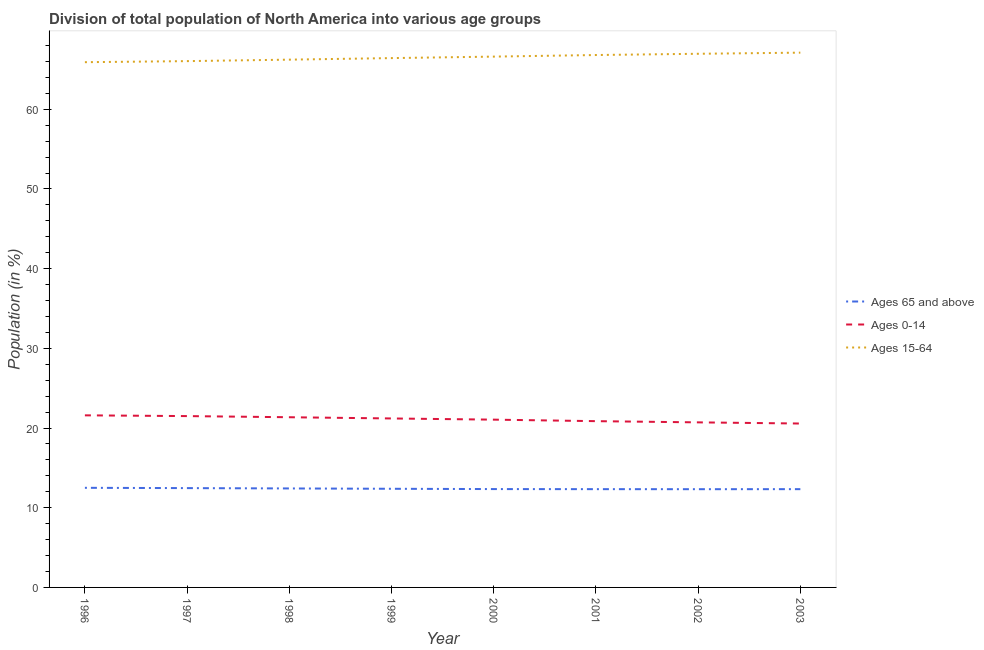How many different coloured lines are there?
Make the answer very short. 3. Does the line corresponding to percentage of population within the age-group 0-14 intersect with the line corresponding to percentage of population within the age-group of 65 and above?
Offer a terse response. No. Is the number of lines equal to the number of legend labels?
Offer a terse response. Yes. What is the percentage of population within the age-group of 65 and above in 1996?
Your answer should be compact. 12.5. Across all years, what is the maximum percentage of population within the age-group of 65 and above?
Ensure brevity in your answer.  12.5. Across all years, what is the minimum percentage of population within the age-group 0-14?
Provide a succinct answer. 20.57. What is the total percentage of population within the age-group of 65 and above in the graph?
Offer a very short reply. 99.09. What is the difference between the percentage of population within the age-group 0-14 in 1998 and that in 2003?
Make the answer very short. 0.79. What is the difference between the percentage of population within the age-group of 65 and above in 1996 and the percentage of population within the age-group 15-64 in 1998?
Offer a terse response. -53.73. What is the average percentage of population within the age-group of 65 and above per year?
Your response must be concise. 12.39. In the year 1998, what is the difference between the percentage of population within the age-group 0-14 and percentage of population within the age-group 15-64?
Offer a very short reply. -44.87. What is the ratio of the percentage of population within the age-group of 65 and above in 1999 to that in 2001?
Ensure brevity in your answer.  1. Is the percentage of population within the age-group 15-64 in 1999 less than that in 2002?
Offer a very short reply. Yes. Is the difference between the percentage of population within the age-group of 65 and above in 1998 and 1999 greater than the difference between the percentage of population within the age-group 0-14 in 1998 and 1999?
Your response must be concise. No. What is the difference between the highest and the second highest percentage of population within the age-group 0-14?
Provide a succinct answer. 0.1. What is the difference between the highest and the lowest percentage of population within the age-group 15-64?
Make the answer very short. 1.2. In how many years, is the percentage of population within the age-group of 65 and above greater than the average percentage of population within the age-group of 65 and above taken over all years?
Your answer should be compact. 3. Is the sum of the percentage of population within the age-group 0-14 in 1997 and 1998 greater than the maximum percentage of population within the age-group of 65 and above across all years?
Offer a terse response. Yes. Is the percentage of population within the age-group of 65 and above strictly less than the percentage of population within the age-group 15-64 over the years?
Ensure brevity in your answer.  Yes. How many lines are there?
Your response must be concise. 3. Are the values on the major ticks of Y-axis written in scientific E-notation?
Make the answer very short. No. Does the graph contain any zero values?
Offer a terse response. No. Does the graph contain grids?
Give a very brief answer. No. What is the title of the graph?
Provide a succinct answer. Division of total population of North America into various age groups
. What is the label or title of the X-axis?
Offer a terse response. Year. What is the label or title of the Y-axis?
Provide a short and direct response. Population (in %). What is the Population (in %) in Ages 65 and above in 1996?
Offer a very short reply. 12.5. What is the Population (in %) in Ages 0-14 in 1996?
Make the answer very short. 21.59. What is the Population (in %) in Ages 15-64 in 1996?
Your answer should be very brief. 65.91. What is the Population (in %) of Ages 65 and above in 1997?
Provide a succinct answer. 12.46. What is the Population (in %) of Ages 0-14 in 1997?
Provide a succinct answer. 21.5. What is the Population (in %) in Ages 15-64 in 1997?
Your answer should be compact. 66.04. What is the Population (in %) in Ages 65 and above in 1998?
Give a very brief answer. 12.42. What is the Population (in %) of Ages 0-14 in 1998?
Ensure brevity in your answer.  21.36. What is the Population (in %) in Ages 15-64 in 1998?
Provide a short and direct response. 66.22. What is the Population (in %) of Ages 65 and above in 1999?
Provide a succinct answer. 12.38. What is the Population (in %) of Ages 0-14 in 1999?
Your answer should be compact. 21.2. What is the Population (in %) of Ages 15-64 in 1999?
Provide a short and direct response. 66.42. What is the Population (in %) of Ages 65 and above in 2000?
Ensure brevity in your answer.  12.34. What is the Population (in %) in Ages 0-14 in 2000?
Provide a succinct answer. 21.05. What is the Population (in %) in Ages 15-64 in 2000?
Offer a terse response. 66.61. What is the Population (in %) of Ages 65 and above in 2001?
Keep it short and to the point. 12.33. What is the Population (in %) of Ages 0-14 in 2001?
Your response must be concise. 20.86. What is the Population (in %) of Ages 15-64 in 2001?
Ensure brevity in your answer.  66.81. What is the Population (in %) in Ages 65 and above in 2002?
Make the answer very short. 12.33. What is the Population (in %) of Ages 0-14 in 2002?
Your answer should be very brief. 20.71. What is the Population (in %) of Ages 15-64 in 2002?
Provide a short and direct response. 66.96. What is the Population (in %) in Ages 65 and above in 2003?
Provide a succinct answer. 12.33. What is the Population (in %) of Ages 0-14 in 2003?
Your answer should be very brief. 20.57. What is the Population (in %) of Ages 15-64 in 2003?
Offer a terse response. 67.1. Across all years, what is the maximum Population (in %) in Ages 65 and above?
Offer a very short reply. 12.5. Across all years, what is the maximum Population (in %) of Ages 0-14?
Your answer should be compact. 21.59. Across all years, what is the maximum Population (in %) in Ages 15-64?
Provide a succinct answer. 67.1. Across all years, what is the minimum Population (in %) in Ages 65 and above?
Keep it short and to the point. 12.33. Across all years, what is the minimum Population (in %) of Ages 0-14?
Your answer should be compact. 20.57. Across all years, what is the minimum Population (in %) in Ages 15-64?
Your answer should be very brief. 65.91. What is the total Population (in %) in Ages 65 and above in the graph?
Your answer should be compact. 99.09. What is the total Population (in %) of Ages 0-14 in the graph?
Give a very brief answer. 168.84. What is the total Population (in %) of Ages 15-64 in the graph?
Offer a terse response. 532.07. What is the difference between the Population (in %) in Ages 65 and above in 1996 and that in 1997?
Provide a short and direct response. 0.04. What is the difference between the Population (in %) in Ages 0-14 in 1996 and that in 1997?
Ensure brevity in your answer.  0.1. What is the difference between the Population (in %) of Ages 15-64 in 1996 and that in 1997?
Your answer should be compact. -0.13. What is the difference between the Population (in %) in Ages 65 and above in 1996 and that in 1998?
Your answer should be very brief. 0.08. What is the difference between the Population (in %) of Ages 0-14 in 1996 and that in 1998?
Give a very brief answer. 0.24. What is the difference between the Population (in %) in Ages 15-64 in 1996 and that in 1998?
Provide a succinct answer. -0.32. What is the difference between the Population (in %) in Ages 65 and above in 1996 and that in 1999?
Give a very brief answer. 0.12. What is the difference between the Population (in %) in Ages 0-14 in 1996 and that in 1999?
Your answer should be very brief. 0.39. What is the difference between the Population (in %) in Ages 15-64 in 1996 and that in 1999?
Offer a very short reply. -0.51. What is the difference between the Population (in %) of Ages 65 and above in 1996 and that in 2000?
Make the answer very short. 0.16. What is the difference between the Population (in %) of Ages 0-14 in 1996 and that in 2000?
Your answer should be very brief. 0.54. What is the difference between the Population (in %) of Ages 15-64 in 1996 and that in 2000?
Your response must be concise. -0.7. What is the difference between the Population (in %) of Ages 65 and above in 1996 and that in 2001?
Your answer should be very brief. 0.17. What is the difference between the Population (in %) of Ages 0-14 in 1996 and that in 2001?
Offer a terse response. 0.73. What is the difference between the Population (in %) of Ages 15-64 in 1996 and that in 2001?
Provide a succinct answer. -0.9. What is the difference between the Population (in %) in Ages 65 and above in 1996 and that in 2002?
Offer a very short reply. 0.17. What is the difference between the Population (in %) of Ages 0-14 in 1996 and that in 2002?
Provide a short and direct response. 0.88. What is the difference between the Population (in %) of Ages 15-64 in 1996 and that in 2002?
Your answer should be very brief. -1.06. What is the difference between the Population (in %) in Ages 65 and above in 1996 and that in 2003?
Provide a short and direct response. 0.17. What is the difference between the Population (in %) of Ages 0-14 in 1996 and that in 2003?
Provide a short and direct response. 1.03. What is the difference between the Population (in %) in Ages 15-64 in 1996 and that in 2003?
Your response must be concise. -1.2. What is the difference between the Population (in %) of Ages 65 and above in 1997 and that in 1998?
Keep it short and to the point. 0.04. What is the difference between the Population (in %) of Ages 0-14 in 1997 and that in 1998?
Make the answer very short. 0.14. What is the difference between the Population (in %) of Ages 15-64 in 1997 and that in 1998?
Your response must be concise. -0.19. What is the difference between the Population (in %) of Ages 65 and above in 1997 and that in 1999?
Give a very brief answer. 0.08. What is the difference between the Population (in %) of Ages 0-14 in 1997 and that in 1999?
Your answer should be very brief. 0.3. What is the difference between the Population (in %) in Ages 15-64 in 1997 and that in 1999?
Keep it short and to the point. -0.38. What is the difference between the Population (in %) in Ages 65 and above in 1997 and that in 2000?
Offer a terse response. 0.12. What is the difference between the Population (in %) in Ages 0-14 in 1997 and that in 2000?
Your answer should be very brief. 0.45. What is the difference between the Population (in %) in Ages 15-64 in 1997 and that in 2000?
Your answer should be very brief. -0.57. What is the difference between the Population (in %) of Ages 65 and above in 1997 and that in 2001?
Your answer should be compact. 0.13. What is the difference between the Population (in %) of Ages 0-14 in 1997 and that in 2001?
Offer a terse response. 0.64. What is the difference between the Population (in %) of Ages 15-64 in 1997 and that in 2001?
Your answer should be compact. -0.77. What is the difference between the Population (in %) in Ages 65 and above in 1997 and that in 2002?
Offer a terse response. 0.14. What is the difference between the Population (in %) of Ages 0-14 in 1997 and that in 2002?
Provide a short and direct response. 0.79. What is the difference between the Population (in %) in Ages 15-64 in 1997 and that in 2002?
Make the answer very short. -0.92. What is the difference between the Population (in %) of Ages 65 and above in 1997 and that in 2003?
Your response must be concise. 0.13. What is the difference between the Population (in %) in Ages 0-14 in 1997 and that in 2003?
Offer a terse response. 0.93. What is the difference between the Population (in %) of Ages 15-64 in 1997 and that in 2003?
Your answer should be very brief. -1.06. What is the difference between the Population (in %) of Ages 65 and above in 1998 and that in 1999?
Your response must be concise. 0.04. What is the difference between the Population (in %) in Ages 0-14 in 1998 and that in 1999?
Keep it short and to the point. 0.15. What is the difference between the Population (in %) of Ages 15-64 in 1998 and that in 1999?
Keep it short and to the point. -0.2. What is the difference between the Population (in %) of Ages 65 and above in 1998 and that in 2000?
Offer a terse response. 0.08. What is the difference between the Population (in %) of Ages 0-14 in 1998 and that in 2000?
Provide a succinct answer. 0.3. What is the difference between the Population (in %) in Ages 15-64 in 1998 and that in 2000?
Your answer should be compact. -0.38. What is the difference between the Population (in %) of Ages 65 and above in 1998 and that in 2001?
Provide a succinct answer. 0.09. What is the difference between the Population (in %) of Ages 0-14 in 1998 and that in 2001?
Offer a very short reply. 0.49. What is the difference between the Population (in %) of Ages 15-64 in 1998 and that in 2001?
Give a very brief answer. -0.58. What is the difference between the Population (in %) in Ages 65 and above in 1998 and that in 2002?
Ensure brevity in your answer.  0.09. What is the difference between the Population (in %) in Ages 0-14 in 1998 and that in 2002?
Make the answer very short. 0.64. What is the difference between the Population (in %) of Ages 15-64 in 1998 and that in 2002?
Provide a short and direct response. -0.74. What is the difference between the Population (in %) of Ages 65 and above in 1998 and that in 2003?
Offer a terse response. 0.09. What is the difference between the Population (in %) of Ages 0-14 in 1998 and that in 2003?
Offer a very short reply. 0.79. What is the difference between the Population (in %) of Ages 15-64 in 1998 and that in 2003?
Your response must be concise. -0.88. What is the difference between the Population (in %) of Ages 65 and above in 1999 and that in 2000?
Your answer should be compact. 0.04. What is the difference between the Population (in %) of Ages 0-14 in 1999 and that in 2000?
Your answer should be very brief. 0.15. What is the difference between the Population (in %) of Ages 15-64 in 1999 and that in 2000?
Provide a succinct answer. -0.19. What is the difference between the Population (in %) of Ages 65 and above in 1999 and that in 2001?
Keep it short and to the point. 0.05. What is the difference between the Population (in %) of Ages 0-14 in 1999 and that in 2001?
Offer a terse response. 0.34. What is the difference between the Population (in %) of Ages 15-64 in 1999 and that in 2001?
Keep it short and to the point. -0.39. What is the difference between the Population (in %) of Ages 65 and above in 1999 and that in 2002?
Provide a short and direct response. 0.05. What is the difference between the Population (in %) in Ages 0-14 in 1999 and that in 2002?
Keep it short and to the point. 0.49. What is the difference between the Population (in %) of Ages 15-64 in 1999 and that in 2002?
Your answer should be compact. -0.54. What is the difference between the Population (in %) in Ages 65 and above in 1999 and that in 2003?
Make the answer very short. 0.05. What is the difference between the Population (in %) in Ages 0-14 in 1999 and that in 2003?
Your answer should be compact. 0.64. What is the difference between the Population (in %) in Ages 15-64 in 1999 and that in 2003?
Your response must be concise. -0.68. What is the difference between the Population (in %) in Ages 65 and above in 2000 and that in 2001?
Your answer should be compact. 0.01. What is the difference between the Population (in %) of Ages 0-14 in 2000 and that in 2001?
Keep it short and to the point. 0.19. What is the difference between the Population (in %) of Ages 15-64 in 2000 and that in 2001?
Make the answer very short. -0.2. What is the difference between the Population (in %) in Ages 65 and above in 2000 and that in 2002?
Offer a terse response. 0.01. What is the difference between the Population (in %) in Ages 0-14 in 2000 and that in 2002?
Make the answer very short. 0.34. What is the difference between the Population (in %) of Ages 15-64 in 2000 and that in 2002?
Make the answer very short. -0.36. What is the difference between the Population (in %) in Ages 65 and above in 2000 and that in 2003?
Offer a terse response. 0.01. What is the difference between the Population (in %) of Ages 0-14 in 2000 and that in 2003?
Provide a short and direct response. 0.49. What is the difference between the Population (in %) of Ages 15-64 in 2000 and that in 2003?
Your answer should be very brief. -0.5. What is the difference between the Population (in %) of Ages 65 and above in 2001 and that in 2002?
Ensure brevity in your answer.  0.01. What is the difference between the Population (in %) in Ages 0-14 in 2001 and that in 2002?
Your response must be concise. 0.15. What is the difference between the Population (in %) in Ages 15-64 in 2001 and that in 2002?
Offer a very short reply. -0.16. What is the difference between the Population (in %) of Ages 65 and above in 2001 and that in 2003?
Make the answer very short. -0. What is the difference between the Population (in %) of Ages 0-14 in 2001 and that in 2003?
Your answer should be compact. 0.3. What is the difference between the Population (in %) in Ages 15-64 in 2001 and that in 2003?
Offer a very short reply. -0.3. What is the difference between the Population (in %) in Ages 65 and above in 2002 and that in 2003?
Your answer should be compact. -0.01. What is the difference between the Population (in %) in Ages 0-14 in 2002 and that in 2003?
Keep it short and to the point. 0.15. What is the difference between the Population (in %) in Ages 15-64 in 2002 and that in 2003?
Offer a terse response. -0.14. What is the difference between the Population (in %) in Ages 65 and above in 1996 and the Population (in %) in Ages 0-14 in 1997?
Offer a terse response. -9. What is the difference between the Population (in %) in Ages 65 and above in 1996 and the Population (in %) in Ages 15-64 in 1997?
Ensure brevity in your answer.  -53.54. What is the difference between the Population (in %) of Ages 0-14 in 1996 and the Population (in %) of Ages 15-64 in 1997?
Your response must be concise. -44.45. What is the difference between the Population (in %) in Ages 65 and above in 1996 and the Population (in %) in Ages 0-14 in 1998?
Your answer should be compact. -8.86. What is the difference between the Population (in %) in Ages 65 and above in 1996 and the Population (in %) in Ages 15-64 in 1998?
Your answer should be compact. -53.73. What is the difference between the Population (in %) in Ages 0-14 in 1996 and the Population (in %) in Ages 15-64 in 1998?
Provide a short and direct response. -44.63. What is the difference between the Population (in %) in Ages 65 and above in 1996 and the Population (in %) in Ages 0-14 in 1999?
Your response must be concise. -8.7. What is the difference between the Population (in %) in Ages 65 and above in 1996 and the Population (in %) in Ages 15-64 in 1999?
Your response must be concise. -53.92. What is the difference between the Population (in %) of Ages 0-14 in 1996 and the Population (in %) of Ages 15-64 in 1999?
Keep it short and to the point. -44.83. What is the difference between the Population (in %) in Ages 65 and above in 1996 and the Population (in %) in Ages 0-14 in 2000?
Your response must be concise. -8.55. What is the difference between the Population (in %) of Ages 65 and above in 1996 and the Population (in %) of Ages 15-64 in 2000?
Keep it short and to the point. -54.11. What is the difference between the Population (in %) of Ages 0-14 in 1996 and the Population (in %) of Ages 15-64 in 2000?
Offer a very short reply. -45.01. What is the difference between the Population (in %) in Ages 65 and above in 1996 and the Population (in %) in Ages 0-14 in 2001?
Provide a succinct answer. -8.36. What is the difference between the Population (in %) in Ages 65 and above in 1996 and the Population (in %) in Ages 15-64 in 2001?
Offer a terse response. -54.31. What is the difference between the Population (in %) in Ages 0-14 in 1996 and the Population (in %) in Ages 15-64 in 2001?
Provide a short and direct response. -45.21. What is the difference between the Population (in %) of Ages 65 and above in 1996 and the Population (in %) of Ages 0-14 in 2002?
Offer a terse response. -8.21. What is the difference between the Population (in %) of Ages 65 and above in 1996 and the Population (in %) of Ages 15-64 in 2002?
Your answer should be very brief. -54.46. What is the difference between the Population (in %) in Ages 0-14 in 1996 and the Population (in %) in Ages 15-64 in 2002?
Your response must be concise. -45.37. What is the difference between the Population (in %) in Ages 65 and above in 1996 and the Population (in %) in Ages 0-14 in 2003?
Your answer should be very brief. -8.07. What is the difference between the Population (in %) of Ages 65 and above in 1996 and the Population (in %) of Ages 15-64 in 2003?
Keep it short and to the point. -54.6. What is the difference between the Population (in %) of Ages 0-14 in 1996 and the Population (in %) of Ages 15-64 in 2003?
Make the answer very short. -45.51. What is the difference between the Population (in %) of Ages 65 and above in 1997 and the Population (in %) of Ages 0-14 in 1998?
Your answer should be very brief. -8.89. What is the difference between the Population (in %) in Ages 65 and above in 1997 and the Population (in %) in Ages 15-64 in 1998?
Offer a terse response. -53.76. What is the difference between the Population (in %) of Ages 0-14 in 1997 and the Population (in %) of Ages 15-64 in 1998?
Your answer should be very brief. -44.73. What is the difference between the Population (in %) in Ages 65 and above in 1997 and the Population (in %) in Ages 0-14 in 1999?
Offer a very short reply. -8.74. What is the difference between the Population (in %) of Ages 65 and above in 1997 and the Population (in %) of Ages 15-64 in 1999?
Make the answer very short. -53.96. What is the difference between the Population (in %) of Ages 0-14 in 1997 and the Population (in %) of Ages 15-64 in 1999?
Your answer should be very brief. -44.92. What is the difference between the Population (in %) in Ages 65 and above in 1997 and the Population (in %) in Ages 0-14 in 2000?
Your answer should be very brief. -8.59. What is the difference between the Population (in %) of Ages 65 and above in 1997 and the Population (in %) of Ages 15-64 in 2000?
Your response must be concise. -54.14. What is the difference between the Population (in %) of Ages 0-14 in 1997 and the Population (in %) of Ages 15-64 in 2000?
Offer a very short reply. -45.11. What is the difference between the Population (in %) of Ages 65 and above in 1997 and the Population (in %) of Ages 0-14 in 2001?
Keep it short and to the point. -8.4. What is the difference between the Population (in %) in Ages 65 and above in 1997 and the Population (in %) in Ages 15-64 in 2001?
Your answer should be very brief. -54.34. What is the difference between the Population (in %) of Ages 0-14 in 1997 and the Population (in %) of Ages 15-64 in 2001?
Make the answer very short. -45.31. What is the difference between the Population (in %) of Ages 65 and above in 1997 and the Population (in %) of Ages 0-14 in 2002?
Give a very brief answer. -8.25. What is the difference between the Population (in %) in Ages 65 and above in 1997 and the Population (in %) in Ages 15-64 in 2002?
Provide a succinct answer. -54.5. What is the difference between the Population (in %) in Ages 0-14 in 1997 and the Population (in %) in Ages 15-64 in 2002?
Give a very brief answer. -45.46. What is the difference between the Population (in %) in Ages 65 and above in 1997 and the Population (in %) in Ages 0-14 in 2003?
Give a very brief answer. -8.1. What is the difference between the Population (in %) of Ages 65 and above in 1997 and the Population (in %) of Ages 15-64 in 2003?
Your answer should be compact. -54.64. What is the difference between the Population (in %) of Ages 0-14 in 1997 and the Population (in %) of Ages 15-64 in 2003?
Your answer should be very brief. -45.6. What is the difference between the Population (in %) in Ages 65 and above in 1998 and the Population (in %) in Ages 0-14 in 1999?
Provide a succinct answer. -8.78. What is the difference between the Population (in %) of Ages 65 and above in 1998 and the Population (in %) of Ages 15-64 in 1999?
Give a very brief answer. -54. What is the difference between the Population (in %) in Ages 0-14 in 1998 and the Population (in %) in Ages 15-64 in 1999?
Give a very brief answer. -45.06. What is the difference between the Population (in %) in Ages 65 and above in 1998 and the Population (in %) in Ages 0-14 in 2000?
Keep it short and to the point. -8.63. What is the difference between the Population (in %) of Ages 65 and above in 1998 and the Population (in %) of Ages 15-64 in 2000?
Provide a succinct answer. -54.19. What is the difference between the Population (in %) of Ages 0-14 in 1998 and the Population (in %) of Ages 15-64 in 2000?
Ensure brevity in your answer.  -45.25. What is the difference between the Population (in %) of Ages 65 and above in 1998 and the Population (in %) of Ages 0-14 in 2001?
Give a very brief answer. -8.44. What is the difference between the Population (in %) of Ages 65 and above in 1998 and the Population (in %) of Ages 15-64 in 2001?
Give a very brief answer. -54.39. What is the difference between the Population (in %) in Ages 0-14 in 1998 and the Population (in %) in Ages 15-64 in 2001?
Your answer should be very brief. -45.45. What is the difference between the Population (in %) in Ages 65 and above in 1998 and the Population (in %) in Ages 0-14 in 2002?
Your answer should be very brief. -8.29. What is the difference between the Population (in %) of Ages 65 and above in 1998 and the Population (in %) of Ages 15-64 in 2002?
Ensure brevity in your answer.  -54.54. What is the difference between the Population (in %) in Ages 0-14 in 1998 and the Population (in %) in Ages 15-64 in 2002?
Offer a terse response. -45.61. What is the difference between the Population (in %) of Ages 65 and above in 1998 and the Population (in %) of Ages 0-14 in 2003?
Your answer should be very brief. -8.15. What is the difference between the Population (in %) in Ages 65 and above in 1998 and the Population (in %) in Ages 15-64 in 2003?
Offer a terse response. -54.68. What is the difference between the Population (in %) of Ages 0-14 in 1998 and the Population (in %) of Ages 15-64 in 2003?
Ensure brevity in your answer.  -45.75. What is the difference between the Population (in %) in Ages 65 and above in 1999 and the Population (in %) in Ages 0-14 in 2000?
Provide a succinct answer. -8.67. What is the difference between the Population (in %) in Ages 65 and above in 1999 and the Population (in %) in Ages 15-64 in 2000?
Provide a succinct answer. -54.23. What is the difference between the Population (in %) of Ages 0-14 in 1999 and the Population (in %) of Ages 15-64 in 2000?
Give a very brief answer. -45.4. What is the difference between the Population (in %) in Ages 65 and above in 1999 and the Population (in %) in Ages 0-14 in 2001?
Your answer should be very brief. -8.49. What is the difference between the Population (in %) of Ages 65 and above in 1999 and the Population (in %) of Ages 15-64 in 2001?
Ensure brevity in your answer.  -54.43. What is the difference between the Population (in %) of Ages 0-14 in 1999 and the Population (in %) of Ages 15-64 in 2001?
Provide a succinct answer. -45.6. What is the difference between the Population (in %) in Ages 65 and above in 1999 and the Population (in %) in Ages 0-14 in 2002?
Offer a terse response. -8.33. What is the difference between the Population (in %) of Ages 65 and above in 1999 and the Population (in %) of Ages 15-64 in 2002?
Give a very brief answer. -54.58. What is the difference between the Population (in %) in Ages 0-14 in 1999 and the Population (in %) in Ages 15-64 in 2002?
Offer a very short reply. -45.76. What is the difference between the Population (in %) of Ages 65 and above in 1999 and the Population (in %) of Ages 0-14 in 2003?
Offer a terse response. -8.19. What is the difference between the Population (in %) of Ages 65 and above in 1999 and the Population (in %) of Ages 15-64 in 2003?
Provide a short and direct response. -54.72. What is the difference between the Population (in %) in Ages 0-14 in 1999 and the Population (in %) in Ages 15-64 in 2003?
Ensure brevity in your answer.  -45.9. What is the difference between the Population (in %) in Ages 65 and above in 2000 and the Population (in %) in Ages 0-14 in 2001?
Offer a very short reply. -8.52. What is the difference between the Population (in %) in Ages 65 and above in 2000 and the Population (in %) in Ages 15-64 in 2001?
Offer a terse response. -54.46. What is the difference between the Population (in %) of Ages 0-14 in 2000 and the Population (in %) of Ages 15-64 in 2001?
Your response must be concise. -45.75. What is the difference between the Population (in %) in Ages 65 and above in 2000 and the Population (in %) in Ages 0-14 in 2002?
Your answer should be compact. -8.37. What is the difference between the Population (in %) of Ages 65 and above in 2000 and the Population (in %) of Ages 15-64 in 2002?
Give a very brief answer. -54.62. What is the difference between the Population (in %) in Ages 0-14 in 2000 and the Population (in %) in Ages 15-64 in 2002?
Make the answer very short. -45.91. What is the difference between the Population (in %) of Ages 65 and above in 2000 and the Population (in %) of Ages 0-14 in 2003?
Ensure brevity in your answer.  -8.22. What is the difference between the Population (in %) of Ages 65 and above in 2000 and the Population (in %) of Ages 15-64 in 2003?
Provide a succinct answer. -54.76. What is the difference between the Population (in %) of Ages 0-14 in 2000 and the Population (in %) of Ages 15-64 in 2003?
Your response must be concise. -46.05. What is the difference between the Population (in %) in Ages 65 and above in 2001 and the Population (in %) in Ages 0-14 in 2002?
Provide a short and direct response. -8.38. What is the difference between the Population (in %) of Ages 65 and above in 2001 and the Population (in %) of Ages 15-64 in 2002?
Your answer should be compact. -54.63. What is the difference between the Population (in %) of Ages 0-14 in 2001 and the Population (in %) of Ages 15-64 in 2002?
Give a very brief answer. -46.1. What is the difference between the Population (in %) in Ages 65 and above in 2001 and the Population (in %) in Ages 0-14 in 2003?
Give a very brief answer. -8.23. What is the difference between the Population (in %) of Ages 65 and above in 2001 and the Population (in %) of Ages 15-64 in 2003?
Your answer should be compact. -54.77. What is the difference between the Population (in %) in Ages 0-14 in 2001 and the Population (in %) in Ages 15-64 in 2003?
Make the answer very short. -46.24. What is the difference between the Population (in %) in Ages 65 and above in 2002 and the Population (in %) in Ages 0-14 in 2003?
Offer a terse response. -8.24. What is the difference between the Population (in %) of Ages 65 and above in 2002 and the Population (in %) of Ages 15-64 in 2003?
Give a very brief answer. -54.78. What is the difference between the Population (in %) of Ages 0-14 in 2002 and the Population (in %) of Ages 15-64 in 2003?
Offer a terse response. -46.39. What is the average Population (in %) of Ages 65 and above per year?
Give a very brief answer. 12.39. What is the average Population (in %) in Ages 0-14 per year?
Your answer should be compact. 21.11. What is the average Population (in %) of Ages 15-64 per year?
Your response must be concise. 66.51. In the year 1996, what is the difference between the Population (in %) in Ages 65 and above and Population (in %) in Ages 0-14?
Your answer should be compact. -9.09. In the year 1996, what is the difference between the Population (in %) of Ages 65 and above and Population (in %) of Ages 15-64?
Your answer should be very brief. -53.41. In the year 1996, what is the difference between the Population (in %) of Ages 0-14 and Population (in %) of Ages 15-64?
Give a very brief answer. -44.31. In the year 1997, what is the difference between the Population (in %) of Ages 65 and above and Population (in %) of Ages 0-14?
Provide a succinct answer. -9.04. In the year 1997, what is the difference between the Population (in %) in Ages 65 and above and Population (in %) in Ages 15-64?
Offer a very short reply. -53.58. In the year 1997, what is the difference between the Population (in %) of Ages 0-14 and Population (in %) of Ages 15-64?
Offer a very short reply. -44.54. In the year 1998, what is the difference between the Population (in %) of Ages 65 and above and Population (in %) of Ages 0-14?
Give a very brief answer. -8.94. In the year 1998, what is the difference between the Population (in %) of Ages 65 and above and Population (in %) of Ages 15-64?
Keep it short and to the point. -53.8. In the year 1998, what is the difference between the Population (in %) of Ages 0-14 and Population (in %) of Ages 15-64?
Your answer should be compact. -44.87. In the year 1999, what is the difference between the Population (in %) of Ages 65 and above and Population (in %) of Ages 0-14?
Your response must be concise. -8.82. In the year 1999, what is the difference between the Population (in %) of Ages 65 and above and Population (in %) of Ages 15-64?
Offer a terse response. -54.04. In the year 1999, what is the difference between the Population (in %) in Ages 0-14 and Population (in %) in Ages 15-64?
Your response must be concise. -45.22. In the year 2000, what is the difference between the Population (in %) of Ages 65 and above and Population (in %) of Ages 0-14?
Your answer should be very brief. -8.71. In the year 2000, what is the difference between the Population (in %) in Ages 65 and above and Population (in %) in Ages 15-64?
Provide a short and direct response. -54.27. In the year 2000, what is the difference between the Population (in %) in Ages 0-14 and Population (in %) in Ages 15-64?
Keep it short and to the point. -45.55. In the year 2001, what is the difference between the Population (in %) of Ages 65 and above and Population (in %) of Ages 0-14?
Provide a succinct answer. -8.53. In the year 2001, what is the difference between the Population (in %) of Ages 65 and above and Population (in %) of Ages 15-64?
Offer a terse response. -54.47. In the year 2001, what is the difference between the Population (in %) in Ages 0-14 and Population (in %) in Ages 15-64?
Your answer should be compact. -45.94. In the year 2002, what is the difference between the Population (in %) in Ages 65 and above and Population (in %) in Ages 0-14?
Ensure brevity in your answer.  -8.39. In the year 2002, what is the difference between the Population (in %) of Ages 65 and above and Population (in %) of Ages 15-64?
Your answer should be compact. -54.64. In the year 2002, what is the difference between the Population (in %) of Ages 0-14 and Population (in %) of Ages 15-64?
Provide a succinct answer. -46.25. In the year 2003, what is the difference between the Population (in %) of Ages 65 and above and Population (in %) of Ages 0-14?
Provide a short and direct response. -8.23. In the year 2003, what is the difference between the Population (in %) of Ages 65 and above and Population (in %) of Ages 15-64?
Your answer should be very brief. -54.77. In the year 2003, what is the difference between the Population (in %) in Ages 0-14 and Population (in %) in Ages 15-64?
Offer a terse response. -46.54. What is the ratio of the Population (in %) of Ages 15-64 in 1996 to that in 1997?
Give a very brief answer. 1. What is the ratio of the Population (in %) of Ages 65 and above in 1996 to that in 1998?
Make the answer very short. 1.01. What is the ratio of the Population (in %) of Ages 0-14 in 1996 to that in 1998?
Keep it short and to the point. 1.01. What is the ratio of the Population (in %) in Ages 15-64 in 1996 to that in 1998?
Give a very brief answer. 1. What is the ratio of the Population (in %) in Ages 65 and above in 1996 to that in 1999?
Offer a terse response. 1.01. What is the ratio of the Population (in %) in Ages 0-14 in 1996 to that in 1999?
Offer a terse response. 1.02. What is the ratio of the Population (in %) in Ages 15-64 in 1996 to that in 1999?
Make the answer very short. 0.99. What is the ratio of the Population (in %) of Ages 65 and above in 1996 to that in 2000?
Give a very brief answer. 1.01. What is the ratio of the Population (in %) in Ages 0-14 in 1996 to that in 2000?
Keep it short and to the point. 1.03. What is the ratio of the Population (in %) of Ages 15-64 in 1996 to that in 2000?
Keep it short and to the point. 0.99. What is the ratio of the Population (in %) in Ages 65 and above in 1996 to that in 2001?
Provide a short and direct response. 1.01. What is the ratio of the Population (in %) of Ages 0-14 in 1996 to that in 2001?
Keep it short and to the point. 1.03. What is the ratio of the Population (in %) in Ages 15-64 in 1996 to that in 2001?
Offer a terse response. 0.99. What is the ratio of the Population (in %) of Ages 65 and above in 1996 to that in 2002?
Your answer should be very brief. 1.01. What is the ratio of the Population (in %) in Ages 0-14 in 1996 to that in 2002?
Your answer should be compact. 1.04. What is the ratio of the Population (in %) of Ages 15-64 in 1996 to that in 2002?
Provide a succinct answer. 0.98. What is the ratio of the Population (in %) of Ages 65 and above in 1996 to that in 2003?
Provide a short and direct response. 1.01. What is the ratio of the Population (in %) of Ages 15-64 in 1996 to that in 2003?
Ensure brevity in your answer.  0.98. What is the ratio of the Population (in %) in Ages 65 and above in 1997 to that in 1998?
Make the answer very short. 1. What is the ratio of the Population (in %) of Ages 15-64 in 1997 to that in 1998?
Your response must be concise. 1. What is the ratio of the Population (in %) of Ages 65 and above in 1997 to that in 1999?
Give a very brief answer. 1.01. What is the ratio of the Population (in %) of Ages 65 and above in 1997 to that in 2000?
Ensure brevity in your answer.  1.01. What is the ratio of the Population (in %) of Ages 0-14 in 1997 to that in 2000?
Ensure brevity in your answer.  1.02. What is the ratio of the Population (in %) in Ages 15-64 in 1997 to that in 2000?
Make the answer very short. 0.99. What is the ratio of the Population (in %) of Ages 65 and above in 1997 to that in 2001?
Keep it short and to the point. 1.01. What is the ratio of the Population (in %) in Ages 0-14 in 1997 to that in 2001?
Keep it short and to the point. 1.03. What is the ratio of the Population (in %) in Ages 0-14 in 1997 to that in 2002?
Ensure brevity in your answer.  1.04. What is the ratio of the Population (in %) in Ages 15-64 in 1997 to that in 2002?
Your response must be concise. 0.99. What is the ratio of the Population (in %) of Ages 65 and above in 1997 to that in 2003?
Your answer should be compact. 1.01. What is the ratio of the Population (in %) in Ages 0-14 in 1997 to that in 2003?
Your answer should be very brief. 1.05. What is the ratio of the Population (in %) in Ages 15-64 in 1997 to that in 2003?
Your response must be concise. 0.98. What is the ratio of the Population (in %) of Ages 65 and above in 1998 to that in 1999?
Keep it short and to the point. 1. What is the ratio of the Population (in %) in Ages 0-14 in 1998 to that in 1999?
Keep it short and to the point. 1.01. What is the ratio of the Population (in %) in Ages 15-64 in 1998 to that in 1999?
Offer a very short reply. 1. What is the ratio of the Population (in %) of Ages 65 and above in 1998 to that in 2000?
Provide a succinct answer. 1.01. What is the ratio of the Population (in %) in Ages 0-14 in 1998 to that in 2000?
Make the answer very short. 1.01. What is the ratio of the Population (in %) of Ages 15-64 in 1998 to that in 2000?
Offer a terse response. 0.99. What is the ratio of the Population (in %) in Ages 0-14 in 1998 to that in 2001?
Your answer should be very brief. 1.02. What is the ratio of the Population (in %) of Ages 65 and above in 1998 to that in 2002?
Give a very brief answer. 1.01. What is the ratio of the Population (in %) of Ages 0-14 in 1998 to that in 2002?
Ensure brevity in your answer.  1.03. What is the ratio of the Population (in %) of Ages 0-14 in 1998 to that in 2003?
Ensure brevity in your answer.  1.04. What is the ratio of the Population (in %) of Ages 15-64 in 1998 to that in 2003?
Make the answer very short. 0.99. What is the ratio of the Population (in %) of Ages 0-14 in 1999 to that in 2000?
Give a very brief answer. 1.01. What is the ratio of the Population (in %) in Ages 15-64 in 1999 to that in 2000?
Keep it short and to the point. 1. What is the ratio of the Population (in %) in Ages 0-14 in 1999 to that in 2001?
Your answer should be compact. 1.02. What is the ratio of the Population (in %) of Ages 15-64 in 1999 to that in 2001?
Provide a short and direct response. 0.99. What is the ratio of the Population (in %) in Ages 65 and above in 1999 to that in 2002?
Offer a very short reply. 1. What is the ratio of the Population (in %) of Ages 0-14 in 1999 to that in 2002?
Ensure brevity in your answer.  1.02. What is the ratio of the Population (in %) in Ages 65 and above in 1999 to that in 2003?
Give a very brief answer. 1. What is the ratio of the Population (in %) in Ages 0-14 in 1999 to that in 2003?
Keep it short and to the point. 1.03. What is the ratio of the Population (in %) in Ages 65 and above in 2000 to that in 2001?
Make the answer very short. 1. What is the ratio of the Population (in %) of Ages 0-14 in 2000 to that in 2001?
Keep it short and to the point. 1.01. What is the ratio of the Population (in %) of Ages 0-14 in 2000 to that in 2002?
Your answer should be compact. 1.02. What is the ratio of the Population (in %) in Ages 65 and above in 2000 to that in 2003?
Make the answer very short. 1. What is the ratio of the Population (in %) of Ages 0-14 in 2000 to that in 2003?
Provide a short and direct response. 1.02. What is the ratio of the Population (in %) in Ages 65 and above in 2001 to that in 2002?
Provide a succinct answer. 1. What is the ratio of the Population (in %) in Ages 0-14 in 2001 to that in 2002?
Give a very brief answer. 1.01. What is the ratio of the Population (in %) of Ages 15-64 in 2001 to that in 2002?
Give a very brief answer. 1. What is the ratio of the Population (in %) of Ages 0-14 in 2001 to that in 2003?
Your answer should be very brief. 1.01. What is the ratio of the Population (in %) in Ages 15-64 in 2001 to that in 2003?
Keep it short and to the point. 1. What is the ratio of the Population (in %) of Ages 0-14 in 2002 to that in 2003?
Provide a succinct answer. 1.01. What is the difference between the highest and the second highest Population (in %) of Ages 65 and above?
Your answer should be very brief. 0.04. What is the difference between the highest and the second highest Population (in %) of Ages 0-14?
Provide a short and direct response. 0.1. What is the difference between the highest and the second highest Population (in %) of Ages 15-64?
Provide a short and direct response. 0.14. What is the difference between the highest and the lowest Population (in %) of Ages 65 and above?
Your response must be concise. 0.17. What is the difference between the highest and the lowest Population (in %) of Ages 0-14?
Give a very brief answer. 1.03. What is the difference between the highest and the lowest Population (in %) in Ages 15-64?
Give a very brief answer. 1.2. 